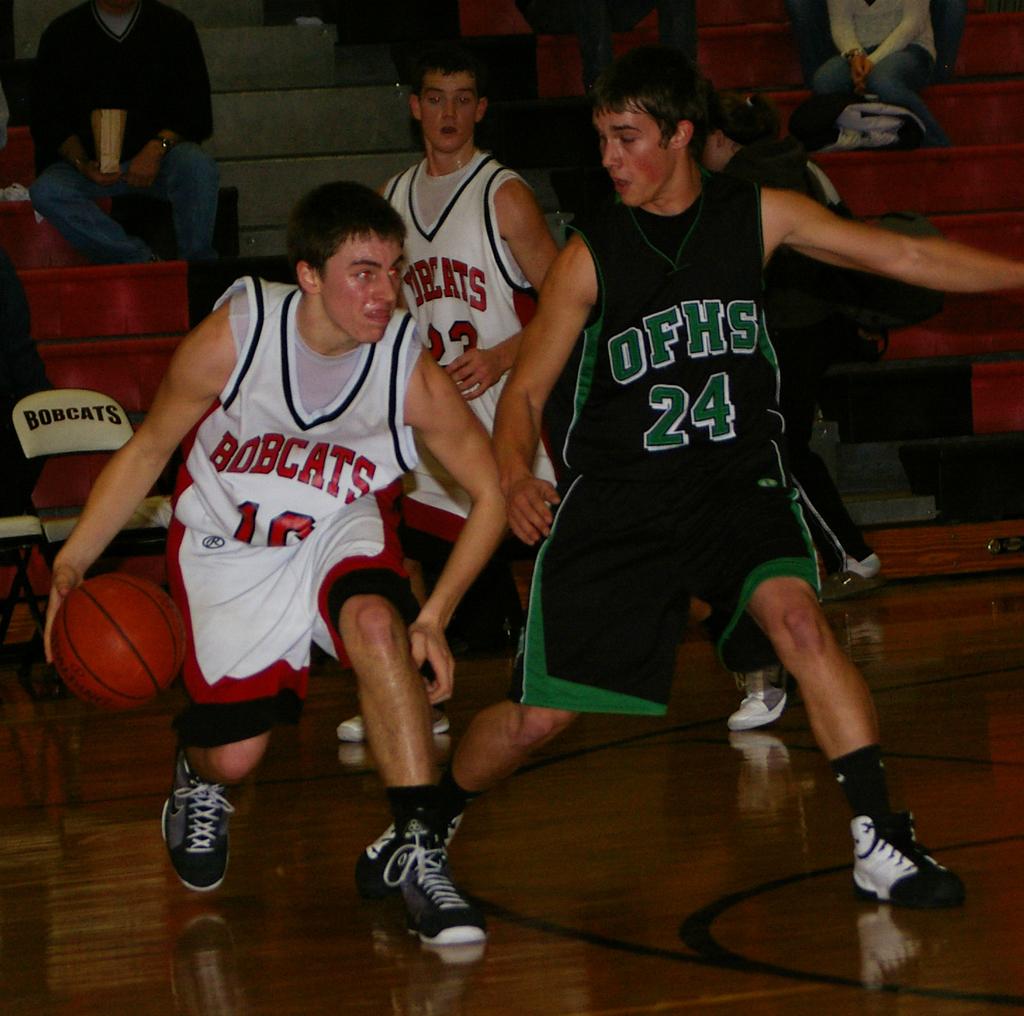What is the team name of the player who has the ball?
Provide a succinct answer. Bobcats. What does it say on the top of number 24?
Make the answer very short. Ofhs. 